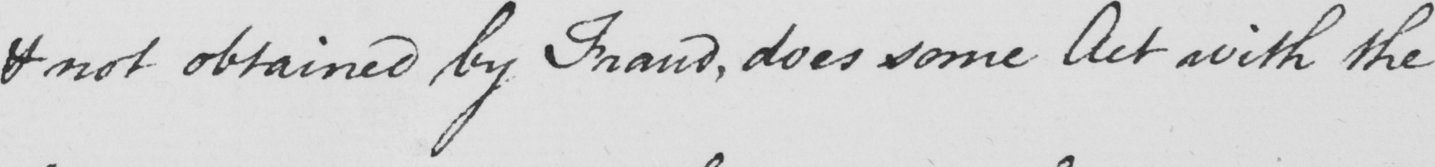Please transcribe the handwritten text in this image. if not obtained by Fraud , does some Act with the 